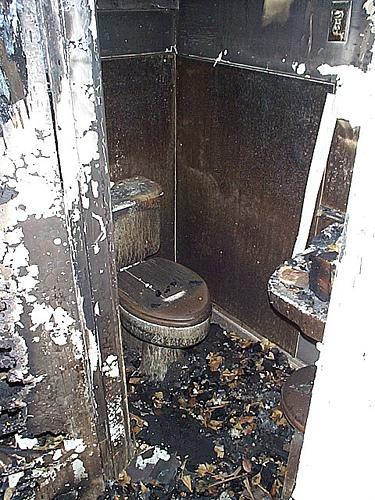What kind of room was this?
Give a very brief answer. Bathroom. What is on the floor?
Keep it brief. Trash. What happened to the room?
Concise answer only. Fire. 